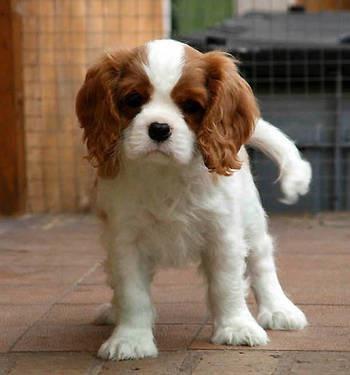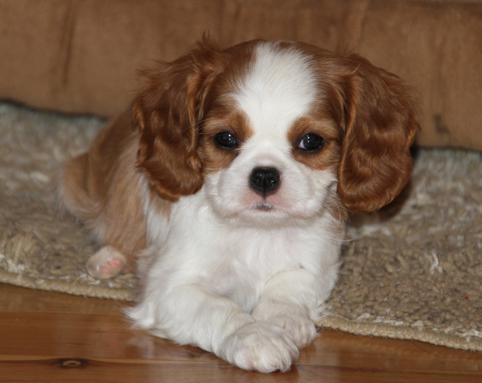The first image is the image on the left, the second image is the image on the right. Evaluate the accuracy of this statement regarding the images: "One of the images shows a dog that is standing.". Is it true? Answer yes or no. Yes. The first image is the image on the left, the second image is the image on the right. Examine the images to the left and right. Is the description "Right image shows a brown and white spaniel on the grass." accurate? Answer yes or no. No. 